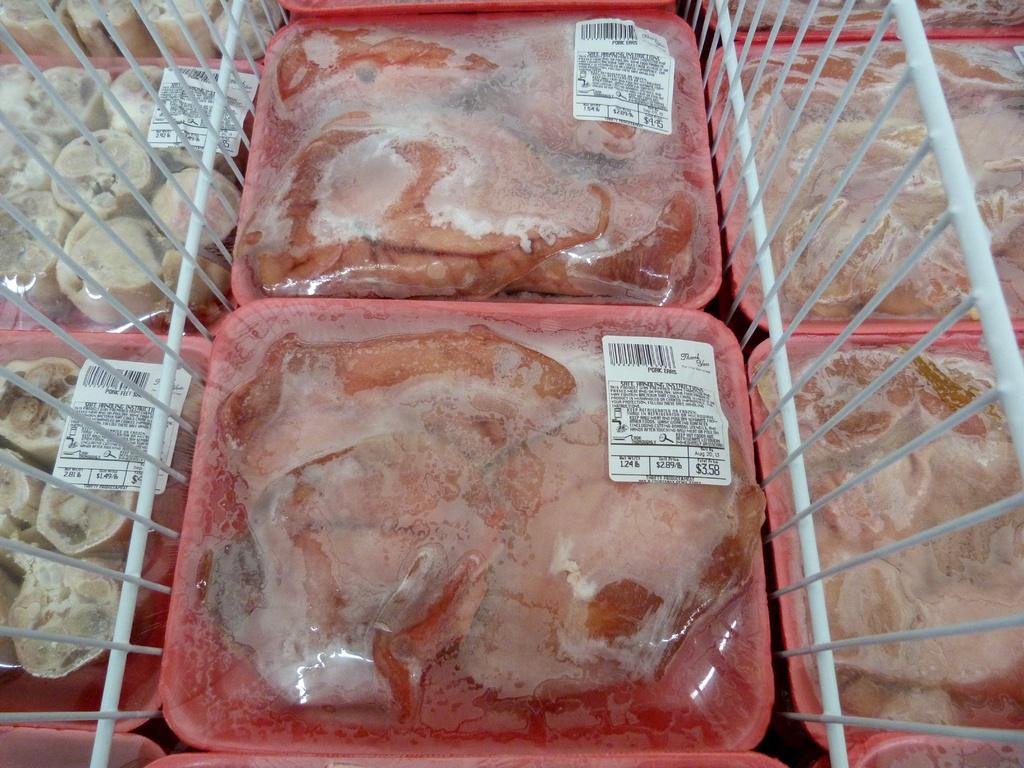What type of food is on the plates in the image? There are plates containing meat in the image. What can be used to cook the meat in the image? There are metal grills visible in the image. What type of seat is visible in the image? There is no seat present in the image. What idea is being conveyed through the image? The image does not convey a specific idea; it simply shows plates containing meat and metal grills. 